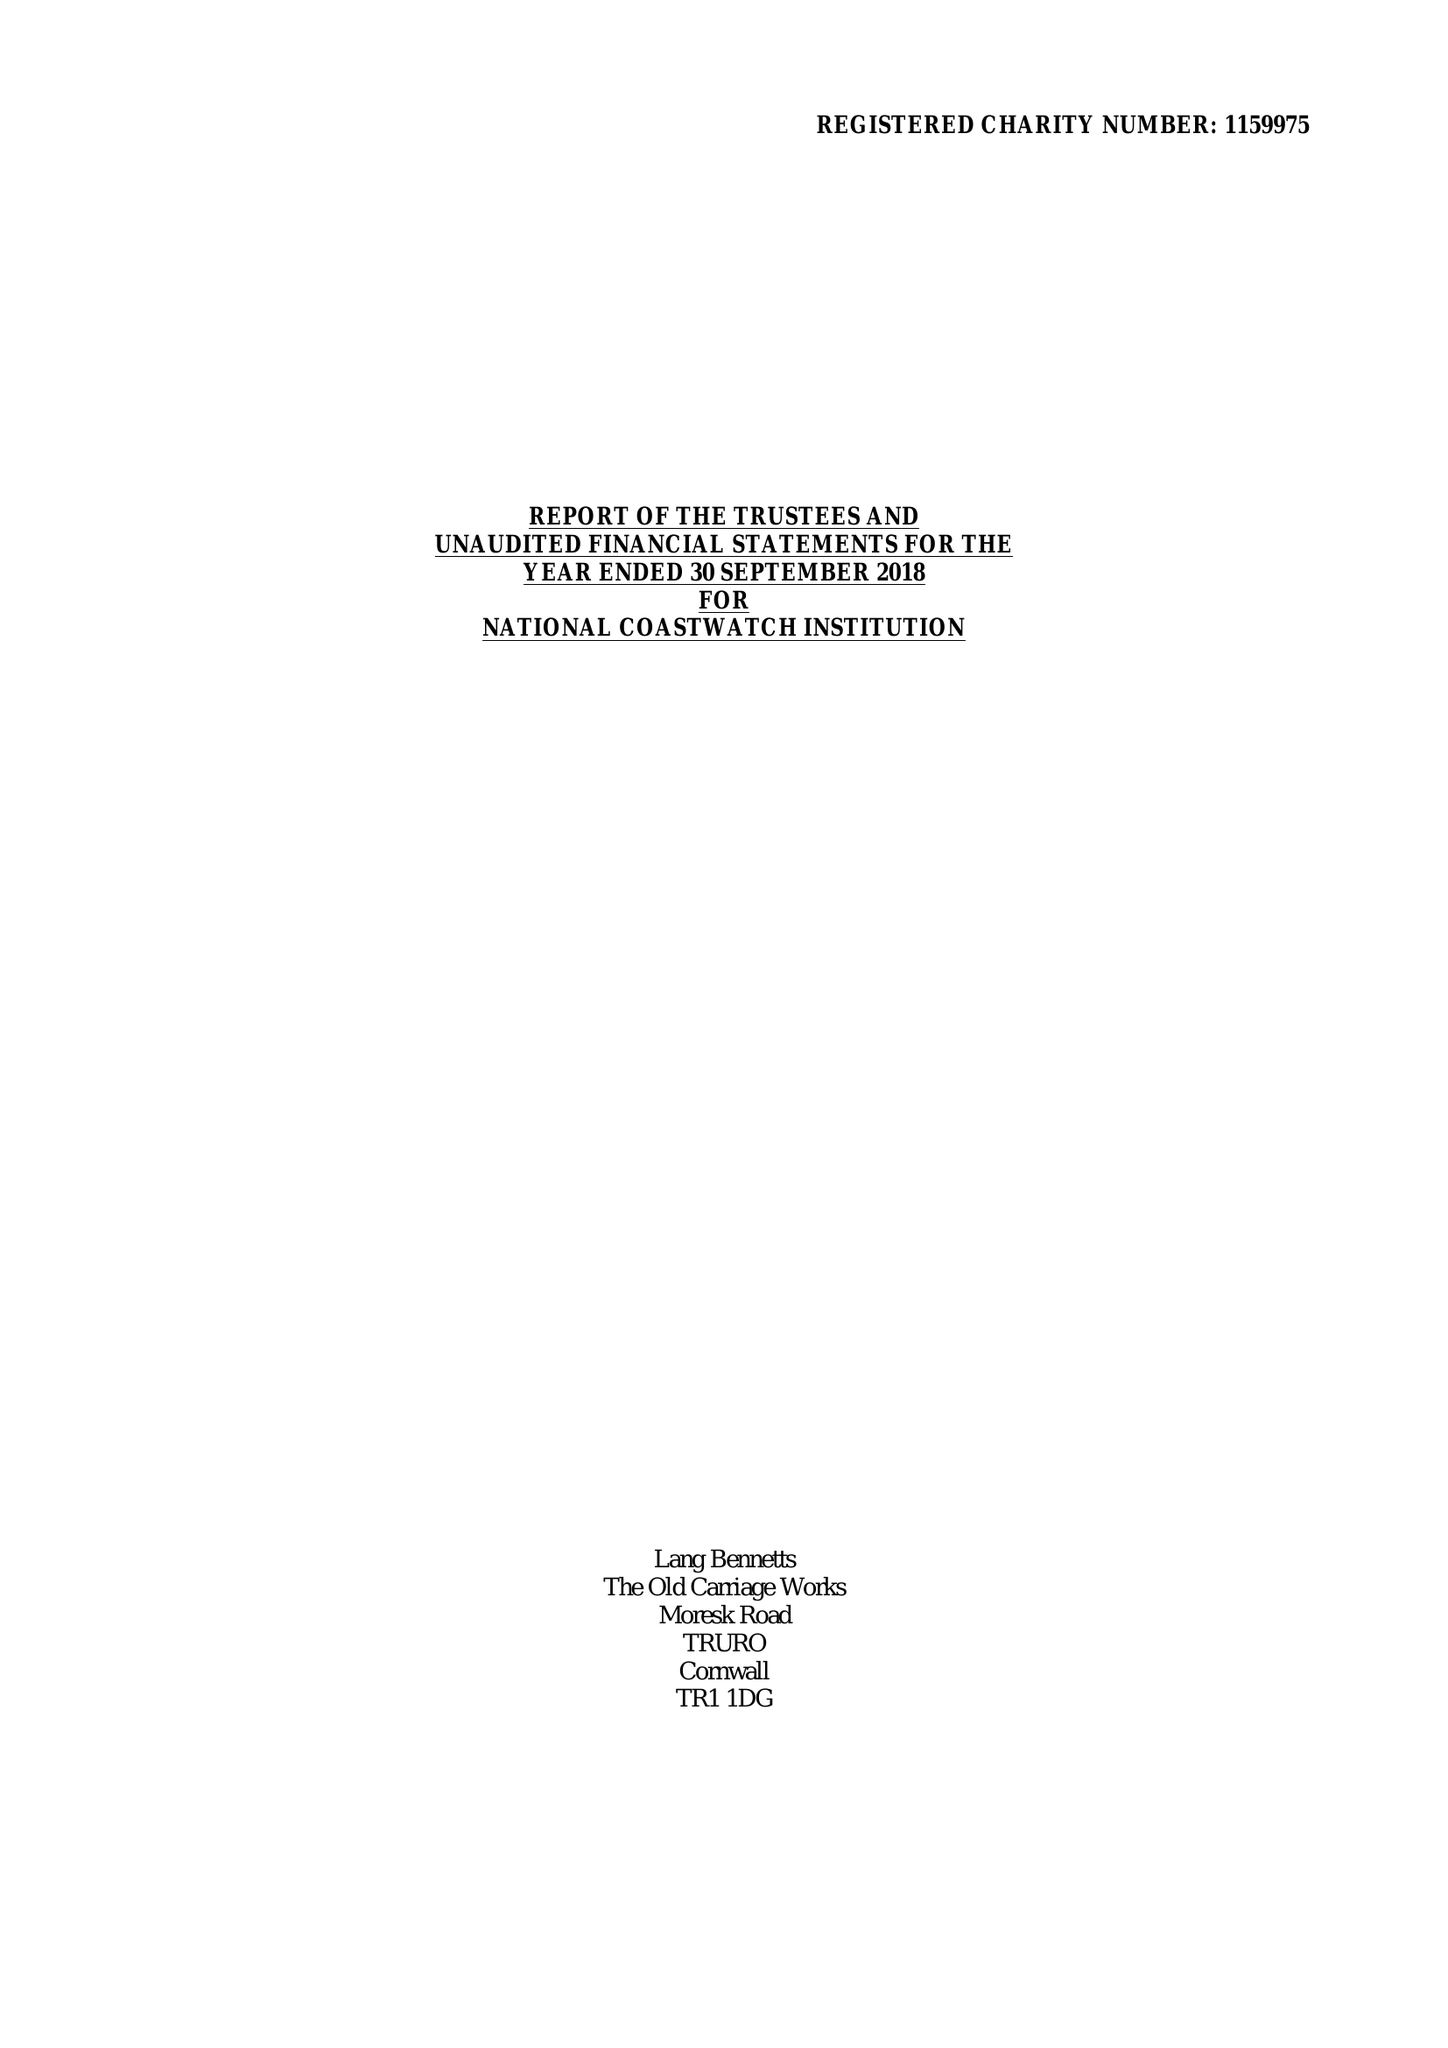What is the value for the charity_number?
Answer the question using a single word or phrase. 1159975 